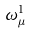<formula> <loc_0><loc_0><loc_500><loc_500>\omega _ { \mu } ^ { 1 }</formula> 